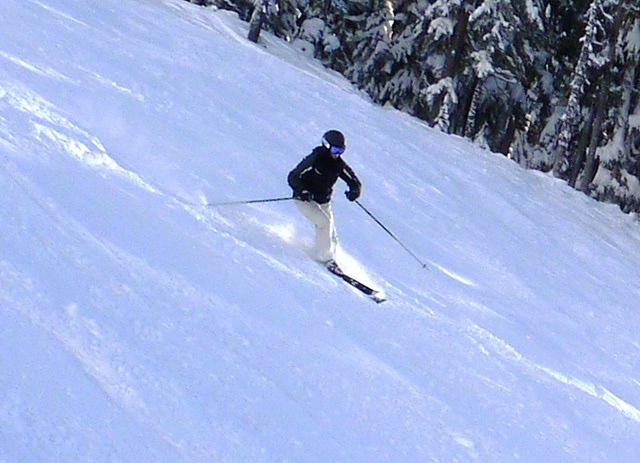Describe the objects in this image and their specific colors. I can see people in lavender, black, and darkgray tones in this image. 